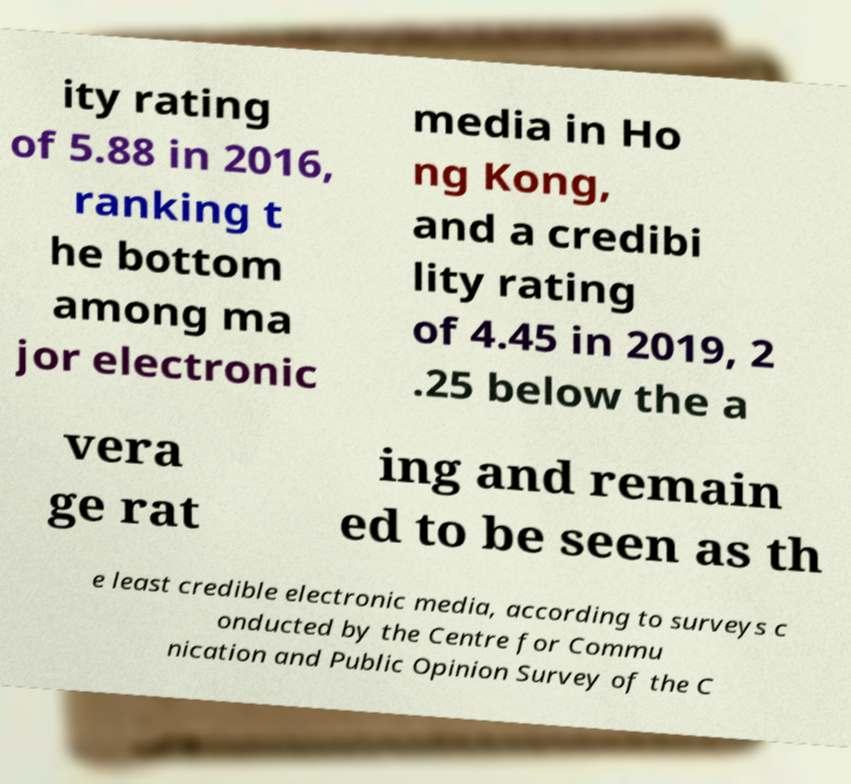Please read and relay the text visible in this image. What does it say? ity rating of 5.88 in 2016, ranking t he bottom among ma jor electronic media in Ho ng Kong, and a credibi lity rating of 4.45 in 2019, 2 .25 below the a vera ge rat ing and remain ed to be seen as th e least credible electronic media, according to surveys c onducted by the Centre for Commu nication and Public Opinion Survey of the C 